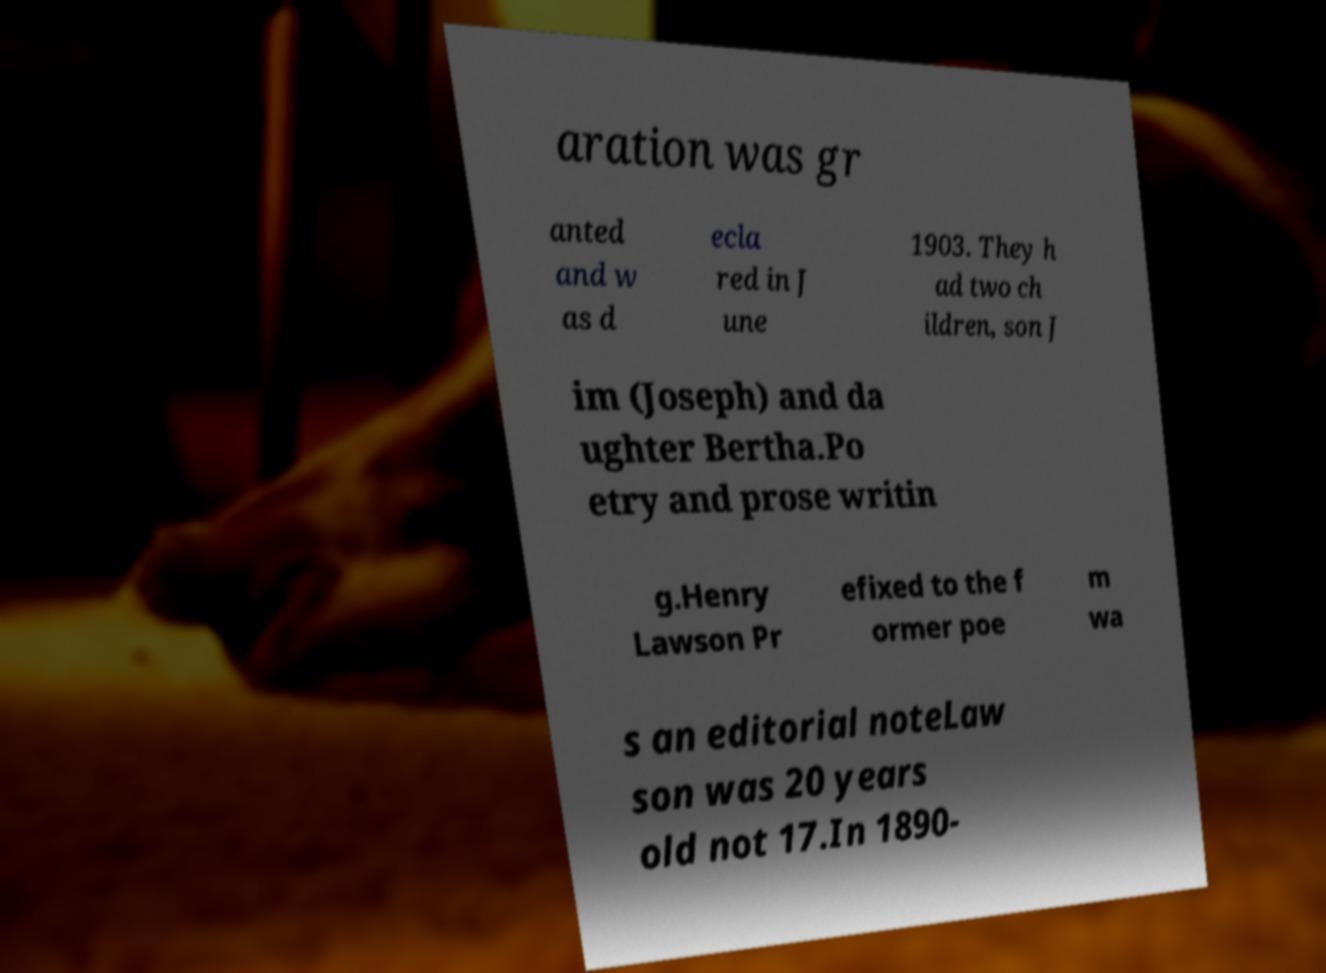Can you accurately transcribe the text from the provided image for me? aration was gr anted and w as d ecla red in J une 1903. They h ad two ch ildren, son J im (Joseph) and da ughter Bertha.Po etry and prose writin g.Henry Lawson Pr efixed to the f ormer poe m wa s an editorial noteLaw son was 20 years old not 17.In 1890- 